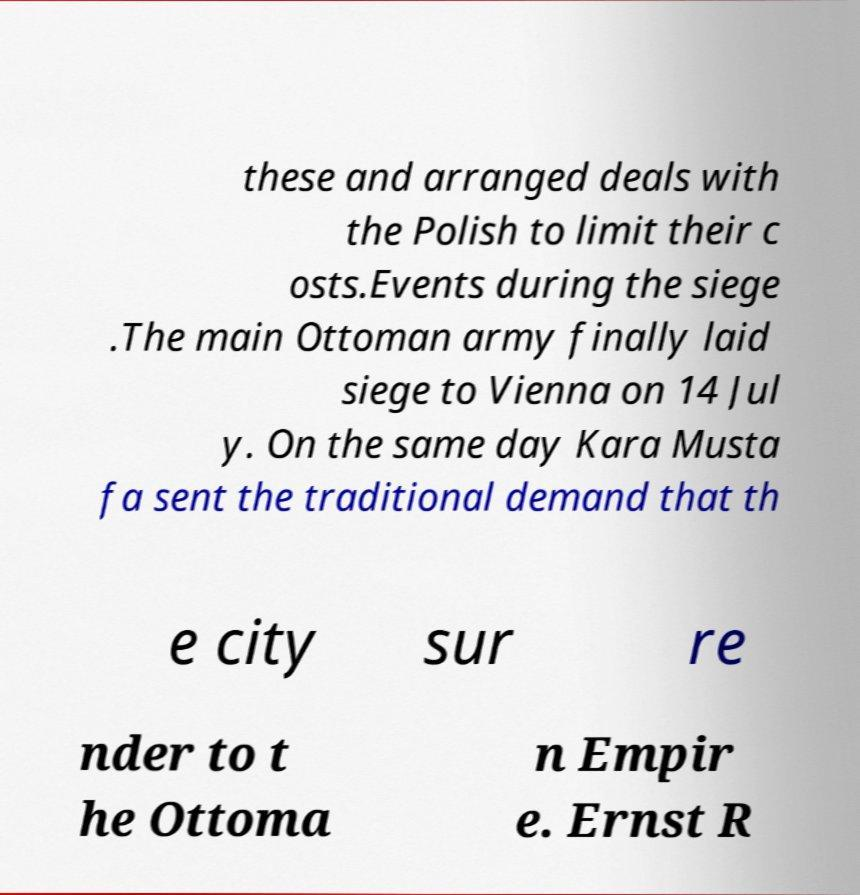Could you extract and type out the text from this image? these and arranged deals with the Polish to limit their c osts.Events during the siege .The main Ottoman army finally laid siege to Vienna on 14 Jul y. On the same day Kara Musta fa sent the traditional demand that th e city sur re nder to t he Ottoma n Empir e. Ernst R 